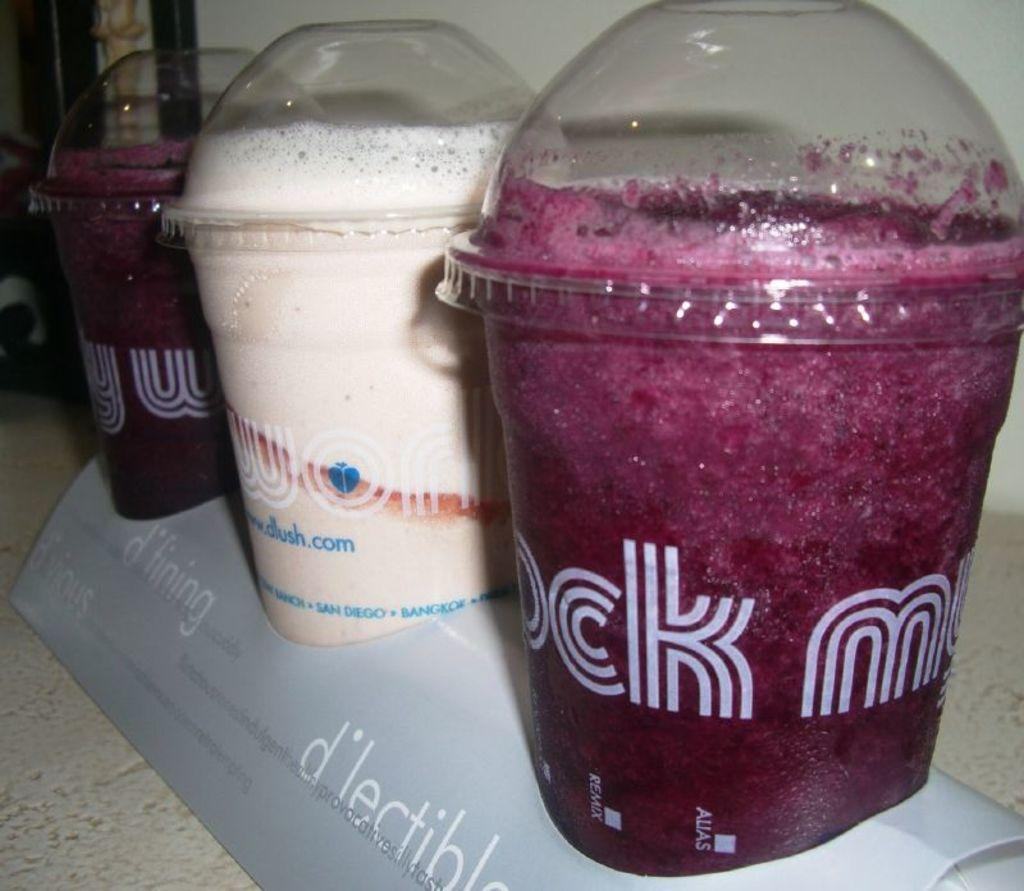Provide a one-sentence caption for the provided image. Three tubs of liquid drunks, the latter of which has the letters CK and M visible. 